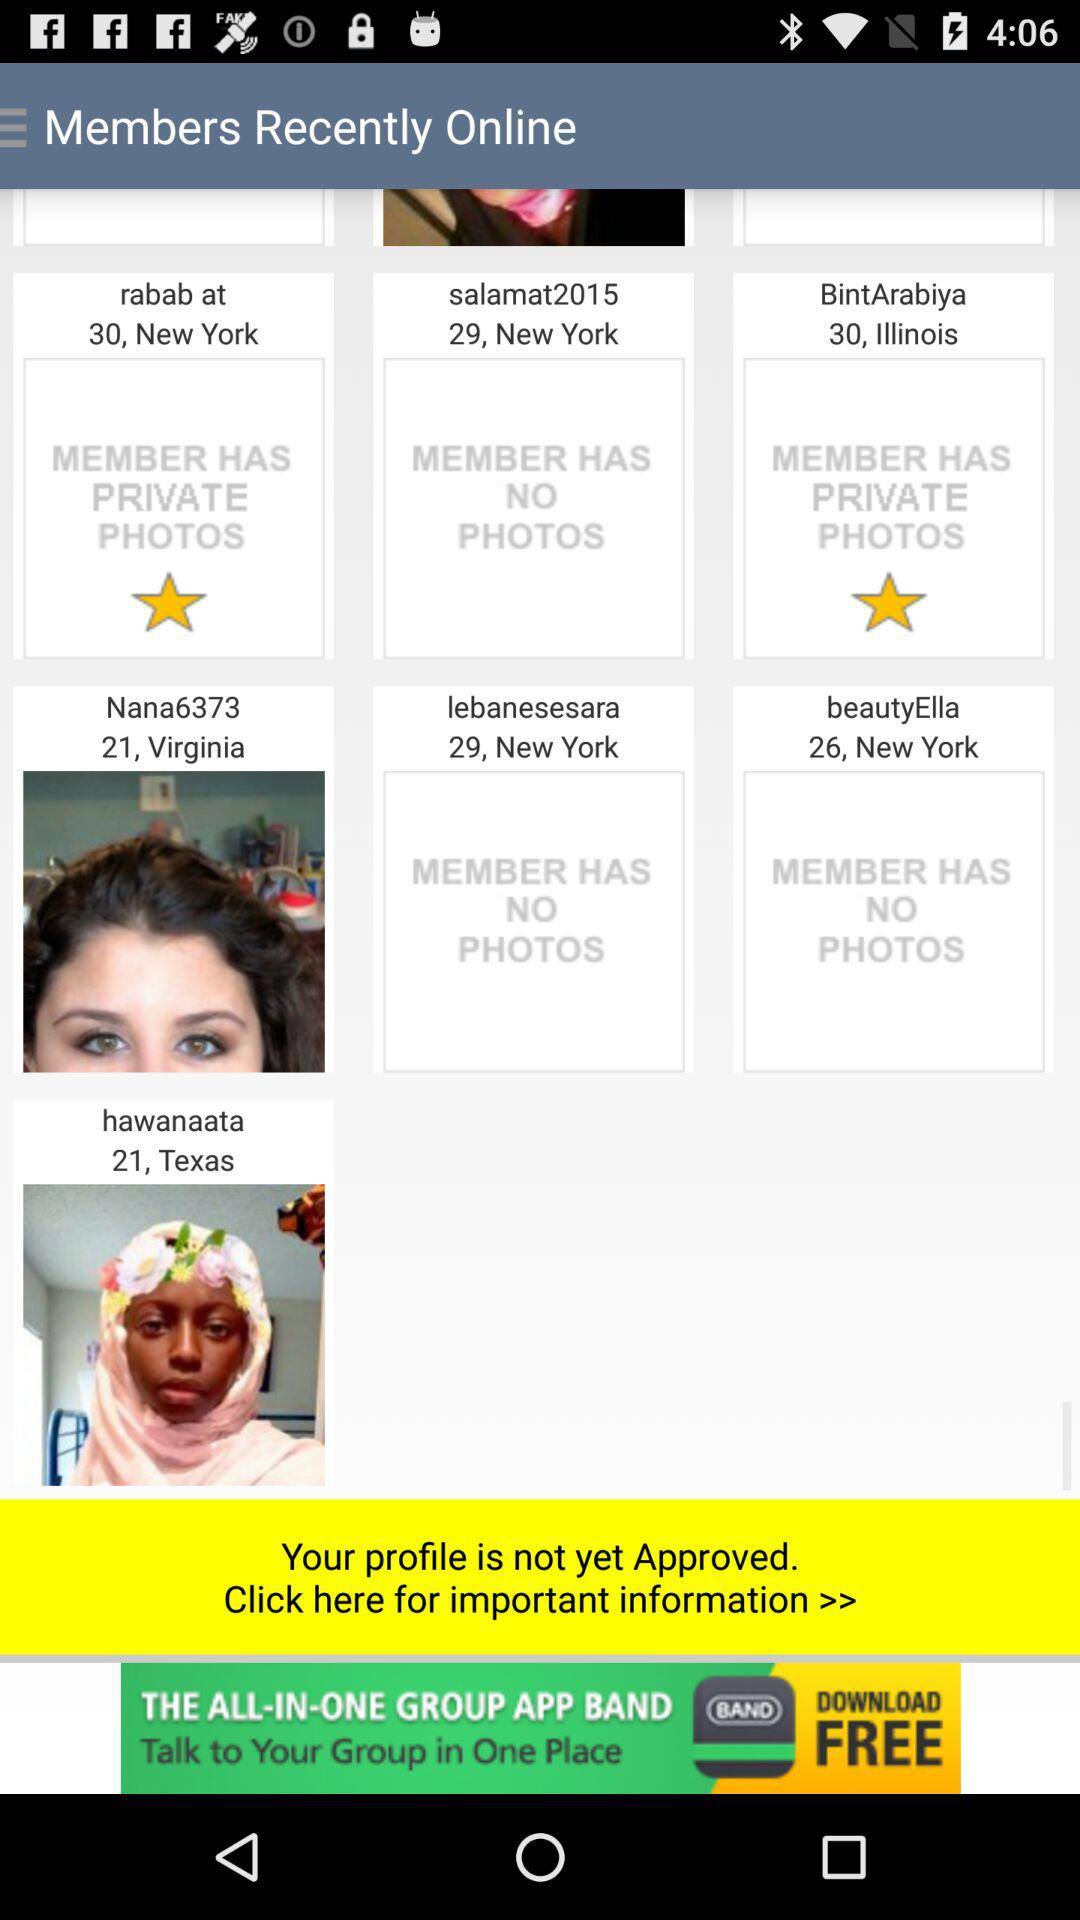Where is Rabab At from? Rabab At is from New York. 